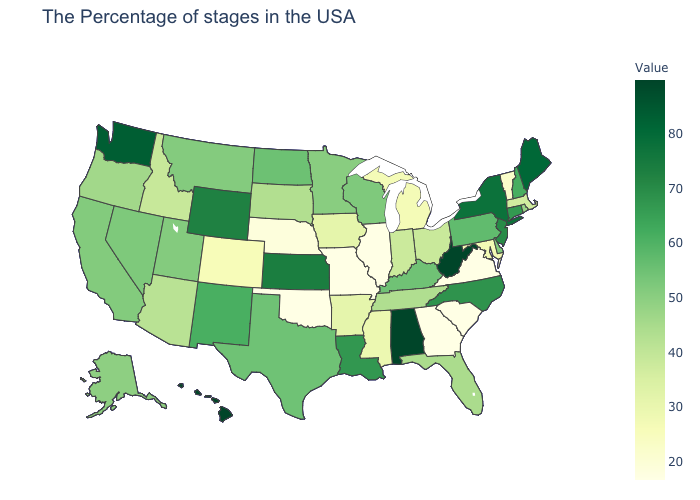Among the states that border Maine , which have the highest value?
Write a very short answer. New Hampshire. Does the map have missing data?
Quick response, please. No. Does West Virginia have the highest value in the South?
Quick response, please. Yes. Does Minnesota have the highest value in the MidWest?
Concise answer only. No. Among the states that border Georgia , does Alabama have the highest value?
Short answer required. Yes. Is the legend a continuous bar?
Write a very short answer. Yes. 